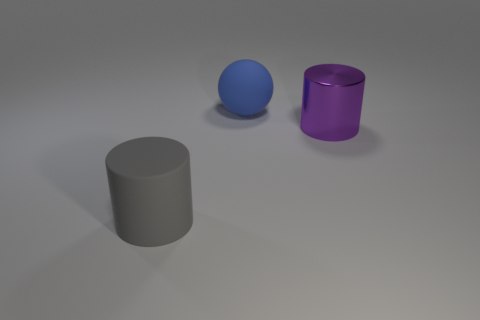Subtract all cylinders. How many objects are left? 1 Add 2 tiny metal objects. How many objects exist? 5 Add 3 big matte things. How many big matte things are left? 5 Add 3 blue balls. How many blue balls exist? 4 Subtract 0 brown balls. How many objects are left? 3 Subtract all small cyan rubber balls. Subtract all big things. How many objects are left? 0 